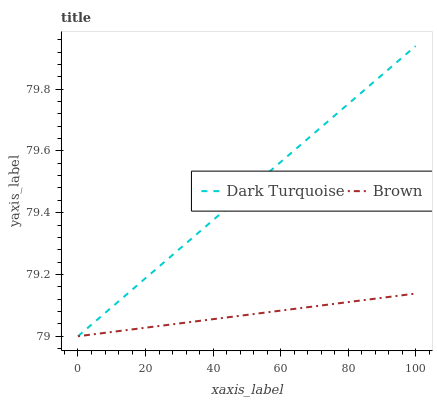Does Brown have the minimum area under the curve?
Answer yes or no. Yes. Does Dark Turquoise have the maximum area under the curve?
Answer yes or no. Yes. Does Brown have the maximum area under the curve?
Answer yes or no. No. Is Brown the smoothest?
Answer yes or no. Yes. Is Dark Turquoise the roughest?
Answer yes or no. Yes. Is Brown the roughest?
Answer yes or no. No. Does Dark Turquoise have the highest value?
Answer yes or no. Yes. Does Brown have the highest value?
Answer yes or no. No. Does Dark Turquoise intersect Brown?
Answer yes or no. Yes. Is Dark Turquoise less than Brown?
Answer yes or no. No. Is Dark Turquoise greater than Brown?
Answer yes or no. No. 